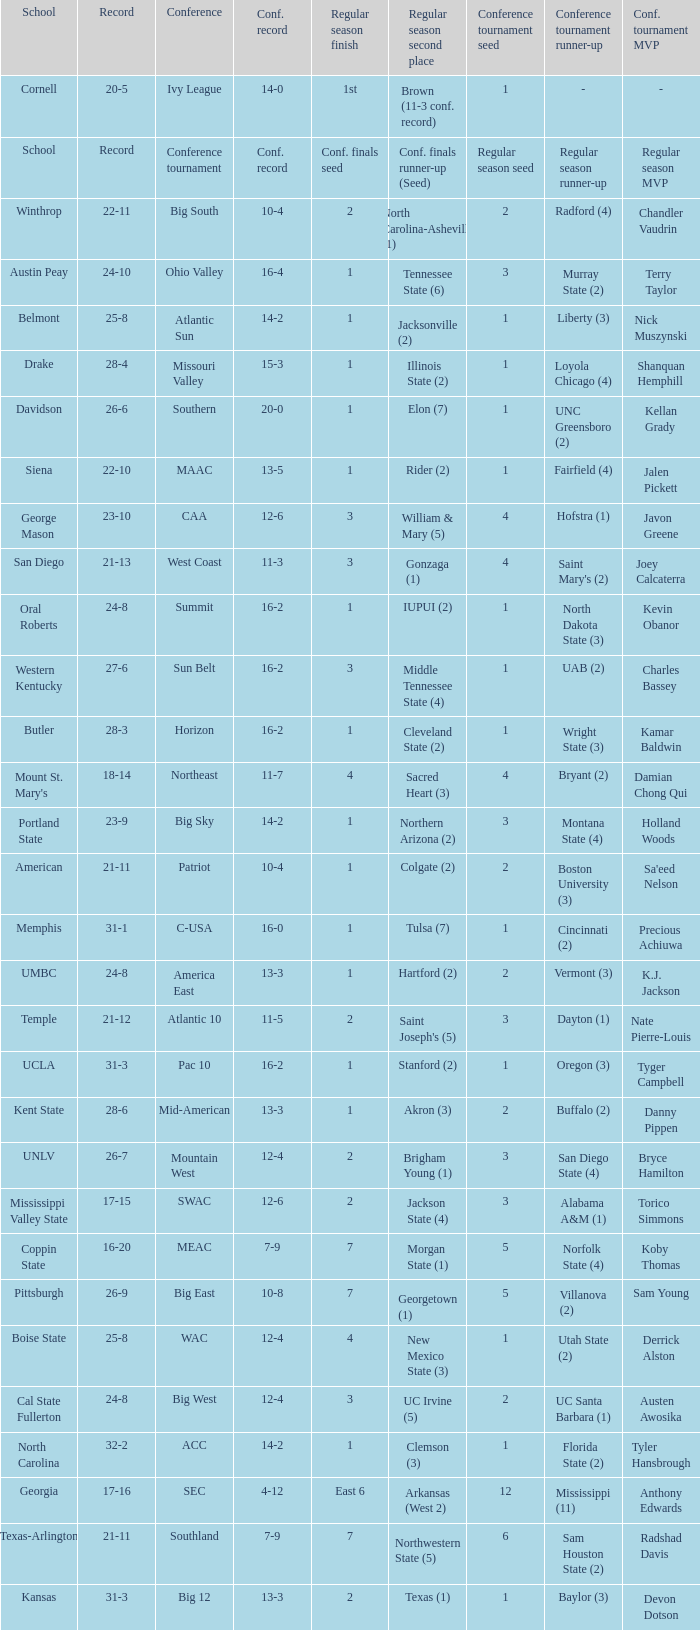What was the overall record of UMBC? 24-8. 